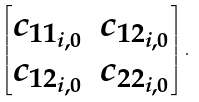Convert formula to latex. <formula><loc_0><loc_0><loc_500><loc_500>\begin{bmatrix} c _ { 1 1 _ { i , 0 } } & c _ { 1 2 _ { i , 0 } } \\ c _ { 1 2 _ { i , 0 } } & c _ { 2 2 _ { i , 0 } } \end{bmatrix} .</formula> 